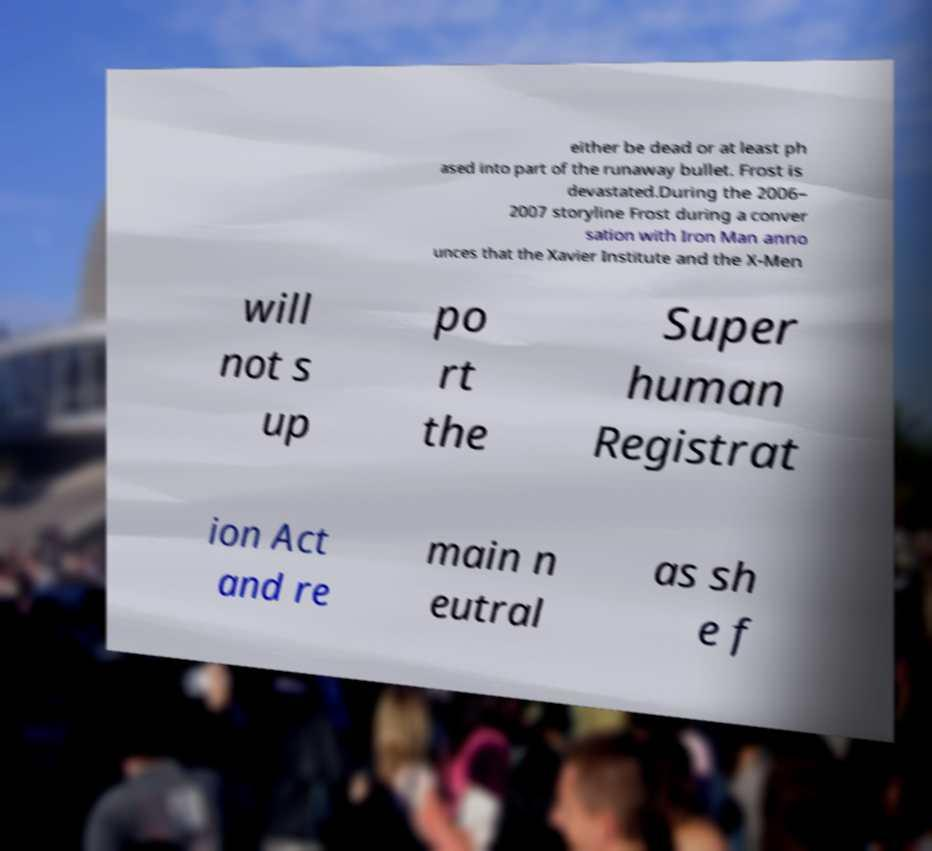Can you read and provide the text displayed in the image?This photo seems to have some interesting text. Can you extract and type it out for me? either be dead or at least ph ased into part of the runaway bullet. Frost is devastated.During the 2006– 2007 storyline Frost during a conver sation with Iron Man anno unces that the Xavier Institute and the X-Men will not s up po rt the Super human Registrat ion Act and re main n eutral as sh e f 